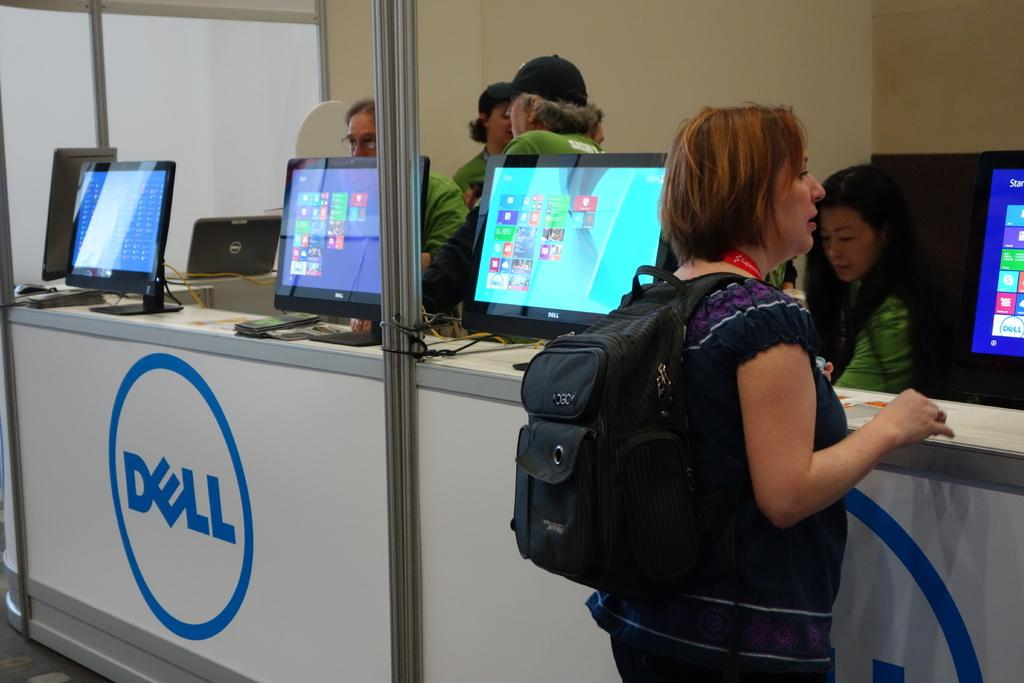What objects are on the table in the image? There are desktops on a table in the image. Who is standing in front of the desktops? A woman is standing in front of the desktops. Can you describe the people behind the desktops? There are people behind the desktops. What can be seen in the background of the image? There is a wall visible in the background of the image. What type of eggnog is being served to the people behind the desktops in the image? There is no eggnog present in the image; it features desktops, a woman, and people behind the desktops. What disease is the woman in front of the desktops suffering from in the image? There is no indication of any disease in the image; it simply shows a woman standing in front of desktops. 